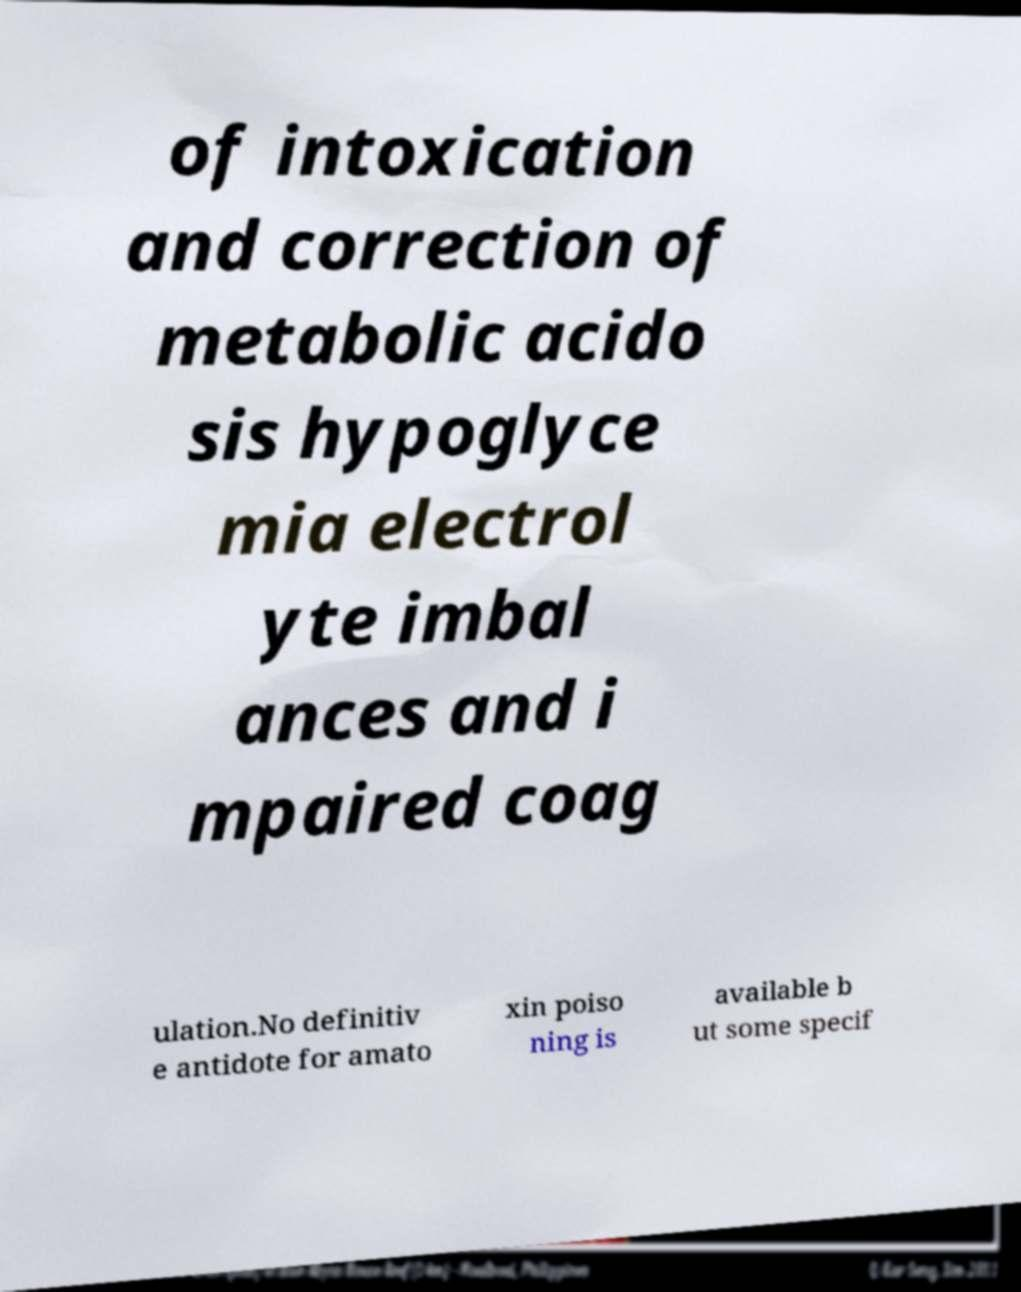Could you extract and type out the text from this image? of intoxication and correction of metabolic acido sis hypoglyce mia electrol yte imbal ances and i mpaired coag ulation.No definitiv e antidote for amato xin poiso ning is available b ut some specif 